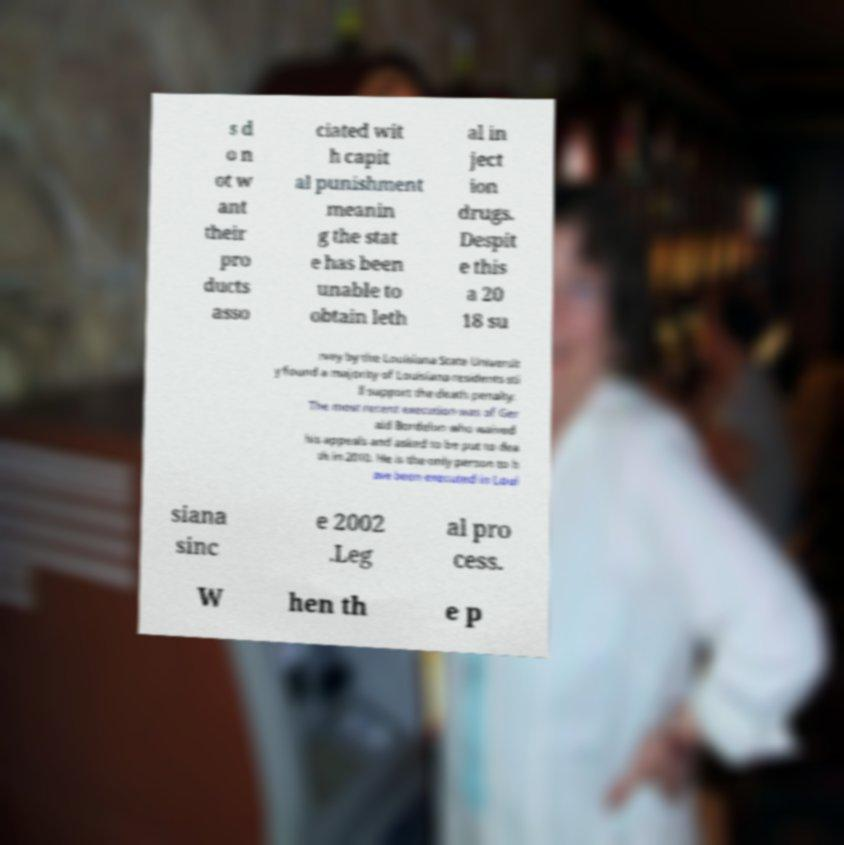Can you accurately transcribe the text from the provided image for me? s d o n ot w ant their pro ducts asso ciated wit h capit al punishment meanin g the stat e has been unable to obtain leth al in ject ion drugs. Despit e this a 20 18 su rvey by the Louisiana State Universit y found a majority of Louisiana residents sti ll support the death penalty. The most recent execution was of Ger ald Bordelon who waived his appeals and asked to be put to dea th in 2010. He is the only person to h ave been executed in Loui siana sinc e 2002 .Leg al pro cess. W hen th e p 